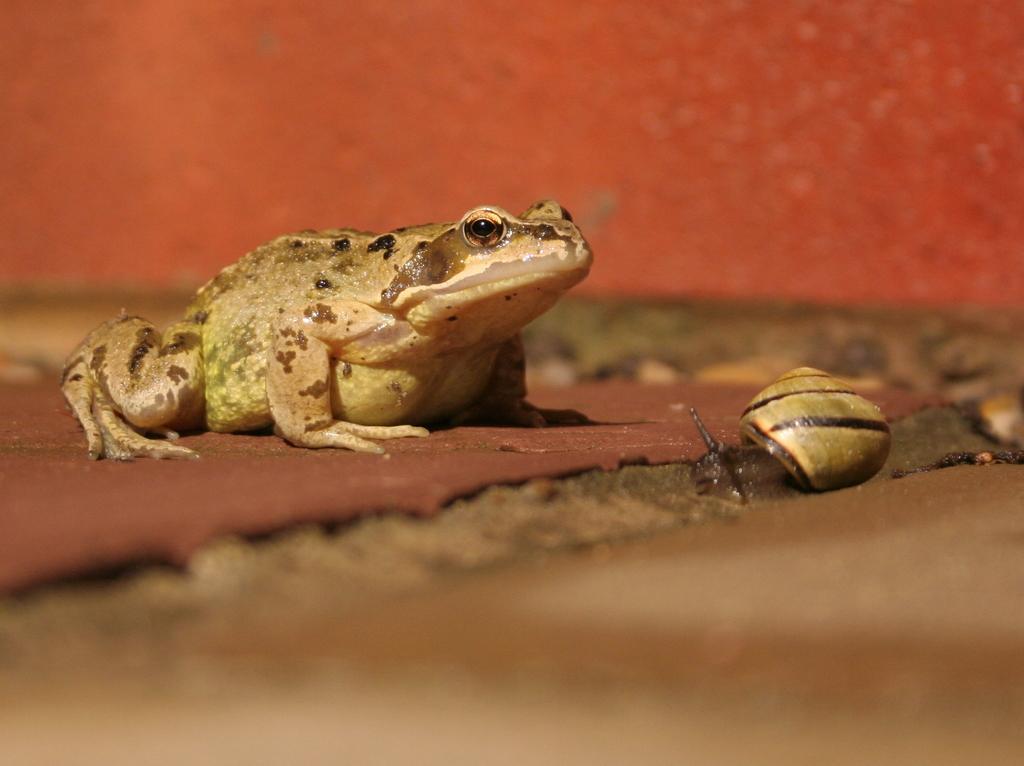Describe this image in one or two sentences. On the left side of the image a frog is there. On the right side of the image a snail is present. At the bottom of the image ground is there. 